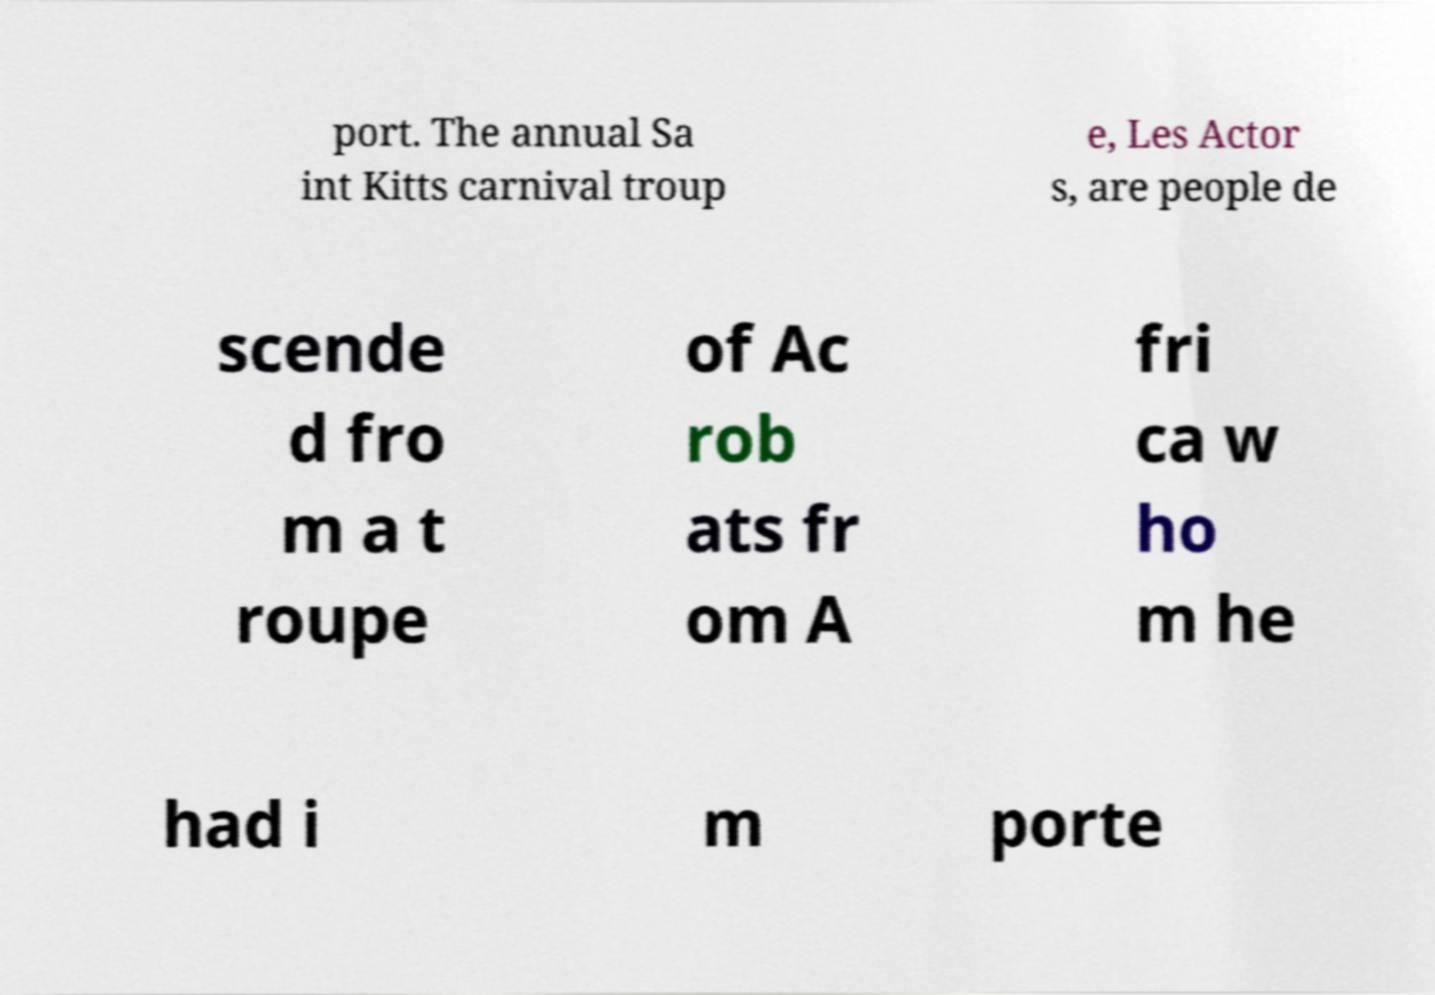Could you assist in decoding the text presented in this image and type it out clearly? port. The annual Sa int Kitts carnival troup e, Les Actor s, are people de scende d fro m a t roupe of Ac rob ats fr om A fri ca w ho m he had i m porte 